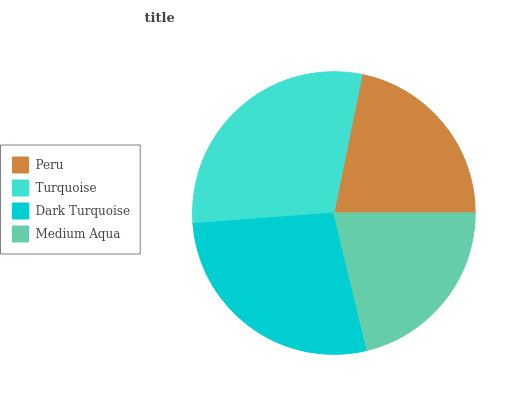Is Medium Aqua the minimum?
Answer yes or no. Yes. Is Turquoise the maximum?
Answer yes or no. Yes. Is Dark Turquoise the minimum?
Answer yes or no. No. Is Dark Turquoise the maximum?
Answer yes or no. No. Is Turquoise greater than Dark Turquoise?
Answer yes or no. Yes. Is Dark Turquoise less than Turquoise?
Answer yes or no. Yes. Is Dark Turquoise greater than Turquoise?
Answer yes or no. No. Is Turquoise less than Dark Turquoise?
Answer yes or no. No. Is Dark Turquoise the high median?
Answer yes or no. Yes. Is Peru the low median?
Answer yes or no. Yes. Is Peru the high median?
Answer yes or no. No. Is Turquoise the low median?
Answer yes or no. No. 